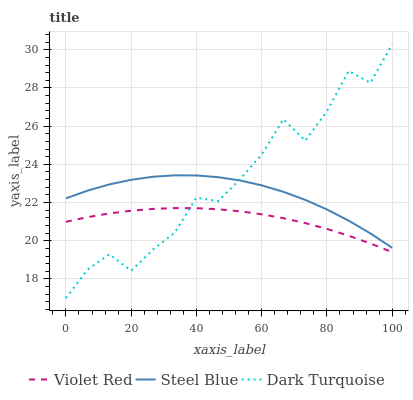Does Violet Red have the minimum area under the curve?
Answer yes or no. Yes. Does Dark Turquoise have the maximum area under the curve?
Answer yes or no. Yes. Does Steel Blue have the minimum area under the curve?
Answer yes or no. No. Does Steel Blue have the maximum area under the curve?
Answer yes or no. No. Is Violet Red the smoothest?
Answer yes or no. Yes. Is Dark Turquoise the roughest?
Answer yes or no. Yes. Is Steel Blue the smoothest?
Answer yes or no. No. Is Steel Blue the roughest?
Answer yes or no. No. Does Dark Turquoise have the lowest value?
Answer yes or no. Yes. Does Violet Red have the lowest value?
Answer yes or no. No. Does Dark Turquoise have the highest value?
Answer yes or no. Yes. Does Steel Blue have the highest value?
Answer yes or no. No. Is Violet Red less than Steel Blue?
Answer yes or no. Yes. Is Steel Blue greater than Violet Red?
Answer yes or no. Yes. Does Dark Turquoise intersect Steel Blue?
Answer yes or no. Yes. Is Dark Turquoise less than Steel Blue?
Answer yes or no. No. Is Dark Turquoise greater than Steel Blue?
Answer yes or no. No. Does Violet Red intersect Steel Blue?
Answer yes or no. No. 